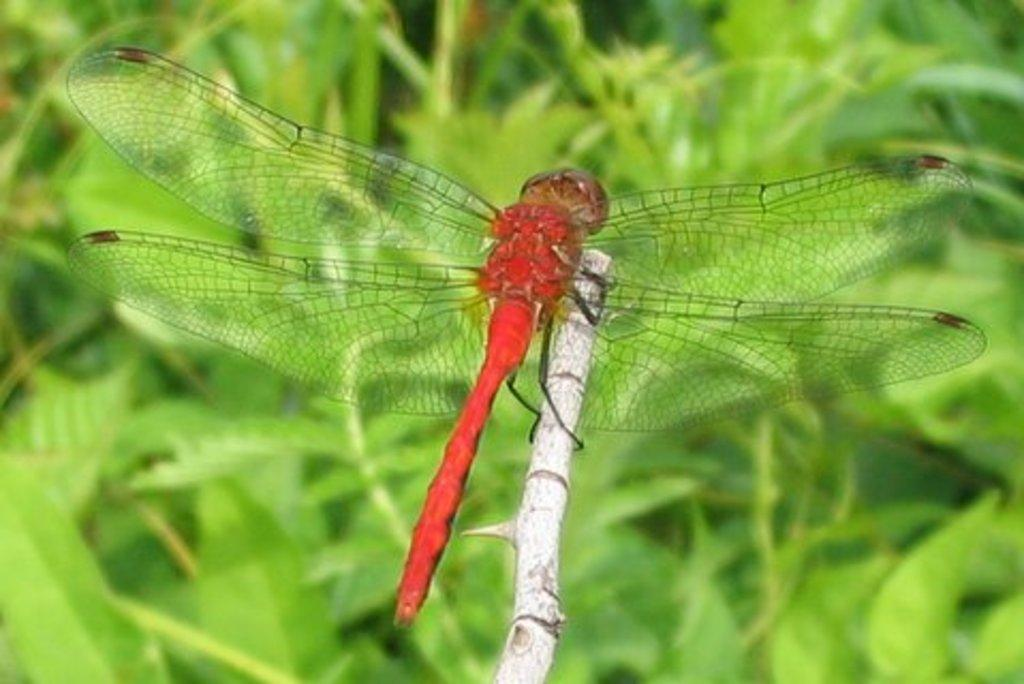What is sitting on the stem in the image? There is a fly sitting on a stem in the image. What can be seen in the background of the image? There are plants in the background of the image. What year is depicted in the image? The image does not depict a specific year; it is a photograph of a fly and plants. What type of harmony can be observed between the fly and the earth in the image? The image does not depict any interaction between the fly and the earth, nor does it show any concept of harmony. 